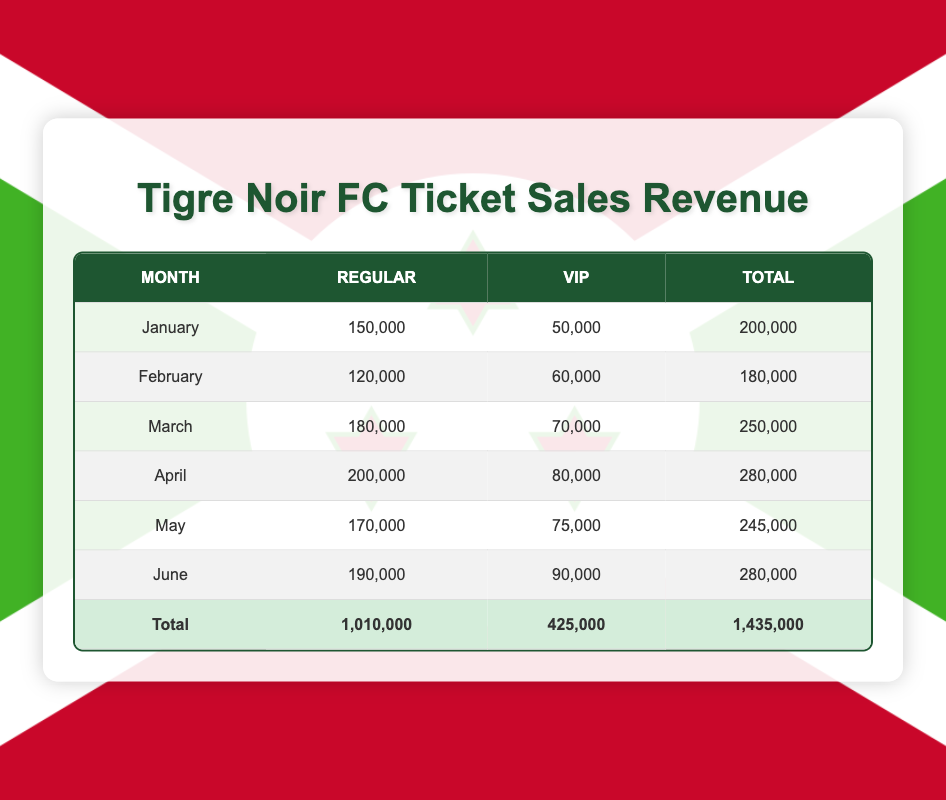What is the total revenue from regular tickets in January? The revenue for regular tickets in January is listed in the table as 150,000.
Answer: 150,000 What is the total revenue from VIP tickets in February? The revenue for VIP tickets in February is given as 60,000 in the table.
Answer: 60,000 Which month had the highest total revenue? The total revenues for each month are: January: 200,000, February: 180,000, March: 250,000, April: 280,000, May: 245,000, June: 280,000. Since April and June both have the highest total of 280,000, they tie for the highest.
Answer: April and June What is the average revenue from regular ticket sales from January to June? The revenues for regular tickets are: 150,000 (Jan), 120,000 (Feb), 180,000 (Mar), 200,000 (Apr), 170,000 (May), and 190,000 (Jun). Adding these gives 1,010,000. Dividing by the number of months, which is 6, gives an average of 1,010,000 / 6 = 168,333.33.
Answer: 168,333.33 Is there any month where VIP ticket revenue exceeded regular ticket revenue? Comparing the VIP revenues with regular revenues: January: 50,000 (VIP) < 150,000 (Regular), February: 60,000 < 120,000, March: 70,000 < 180,000, April: 80,000 < 200,000, May: 75,000 < 170,000, June: 90,000 < 190,000. In none of the months did the VIP exceed the regular ticket sales.
Answer: No What is the difference in total revenue between May and February? The total revenue for May is 245,000 and for February is 180,000. The difference is calculated as 245,000 - 180,000 = 65,000.
Answer: 65,000 Which category had a higher total revenue across all months? The total revenue from regular tickets is 1,010,000 and for VIP tickets, it is 425,000. Clearly, 1,010,000 (regular) is greater than 425,000 (VIP).
Answer: Regular Is the total revenue for April higher than the total revenue for March? The total revenue for April is 280,000 and for March, it's 250,000. Since 280,000 is greater than 250,000, April’s revenue exceeds March’s revenue.
Answer: Yes 